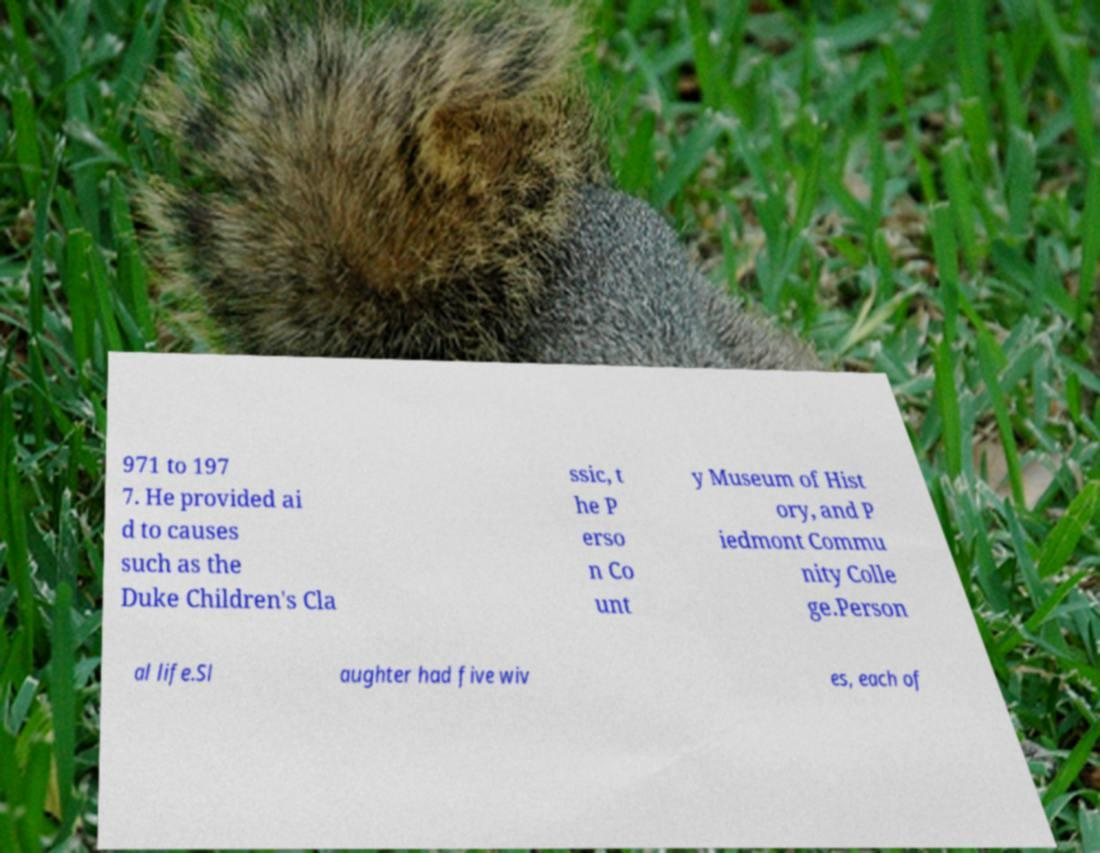Can you read and provide the text displayed in the image?This photo seems to have some interesting text. Can you extract and type it out for me? 971 to 197 7. He provided ai d to causes such as the Duke Children's Cla ssic, t he P erso n Co unt y Museum of Hist ory, and P iedmont Commu nity Colle ge.Person al life.Sl aughter had five wiv es, each of 